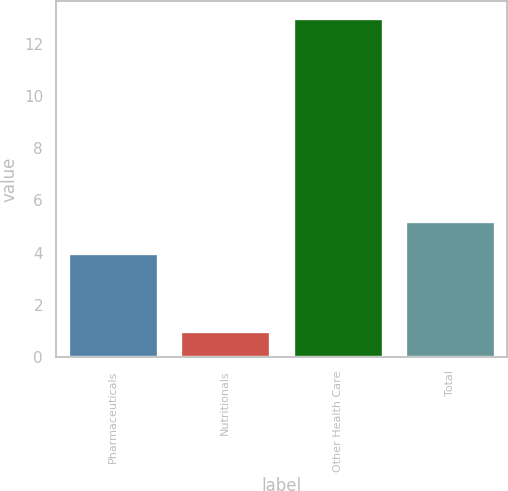<chart> <loc_0><loc_0><loc_500><loc_500><bar_chart><fcel>Pharmaceuticals<fcel>Nutritionals<fcel>Other Health Care<fcel>Total<nl><fcel>4<fcel>1<fcel>13<fcel>5.2<nl></chart> 